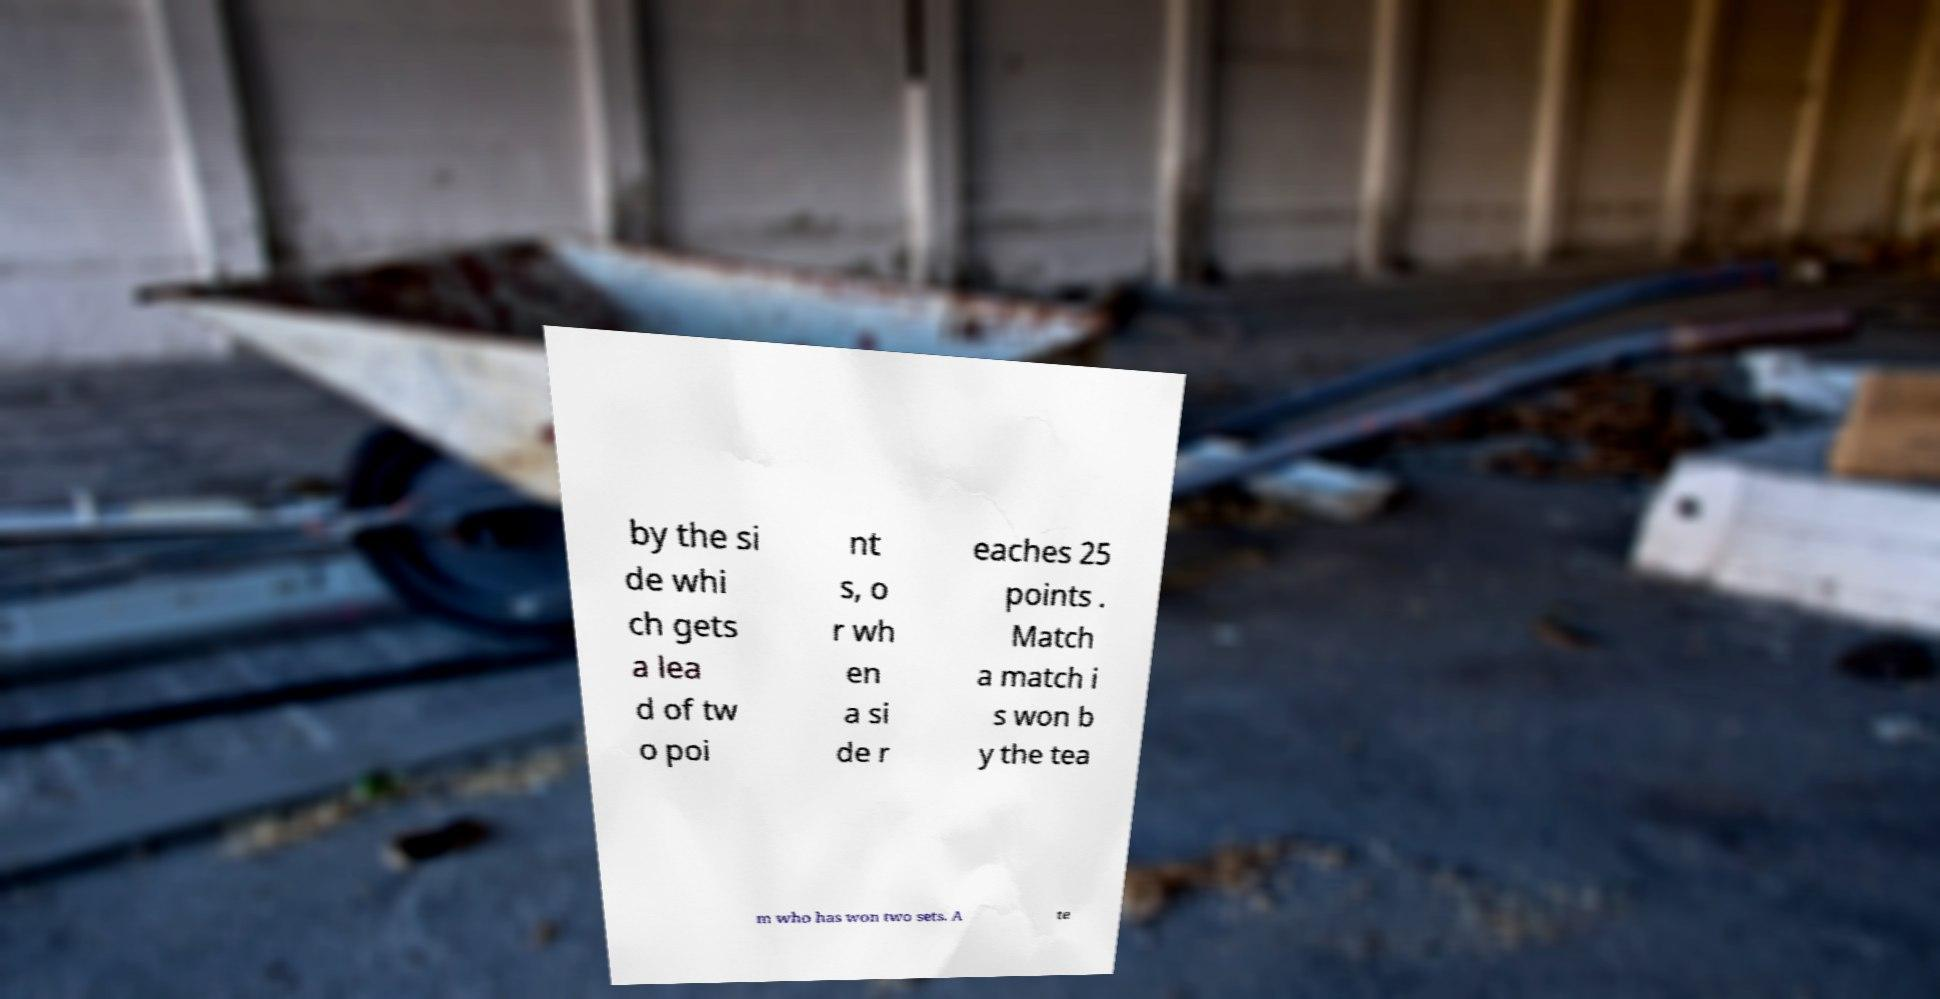Can you accurately transcribe the text from the provided image for me? by the si de whi ch gets a lea d of tw o poi nt s, o r wh en a si de r eaches 25 points . Match a match i s won b y the tea m who has won two sets. A te 